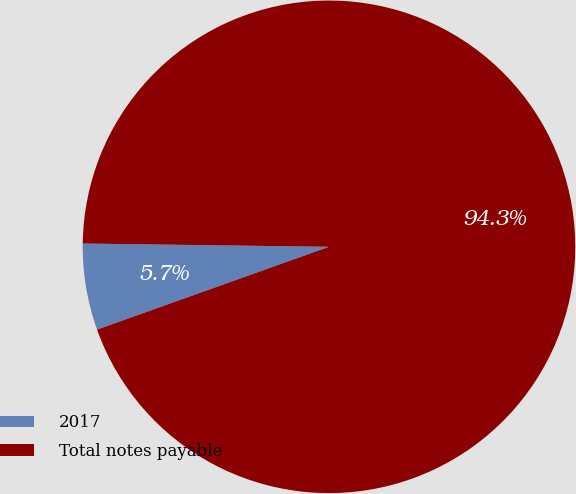Convert chart to OTSL. <chart><loc_0><loc_0><loc_500><loc_500><pie_chart><fcel>2017<fcel>Total notes payable<nl><fcel>5.67%<fcel>94.33%<nl></chart> 